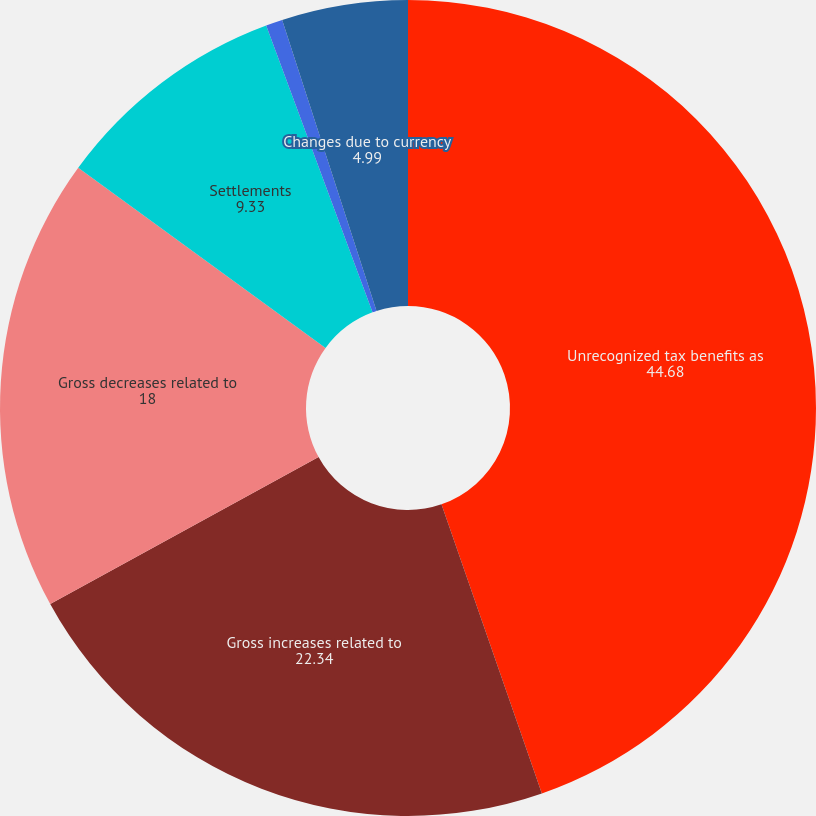Convert chart to OTSL. <chart><loc_0><loc_0><loc_500><loc_500><pie_chart><fcel>Unrecognized tax benefits as<fcel>Gross increases related to<fcel>Gross decreases related to<fcel>Settlements<fcel>Lapse of statute of<fcel>Changes due to currency<nl><fcel>44.68%<fcel>22.34%<fcel>18.0%<fcel>9.33%<fcel>0.66%<fcel>4.99%<nl></chart> 